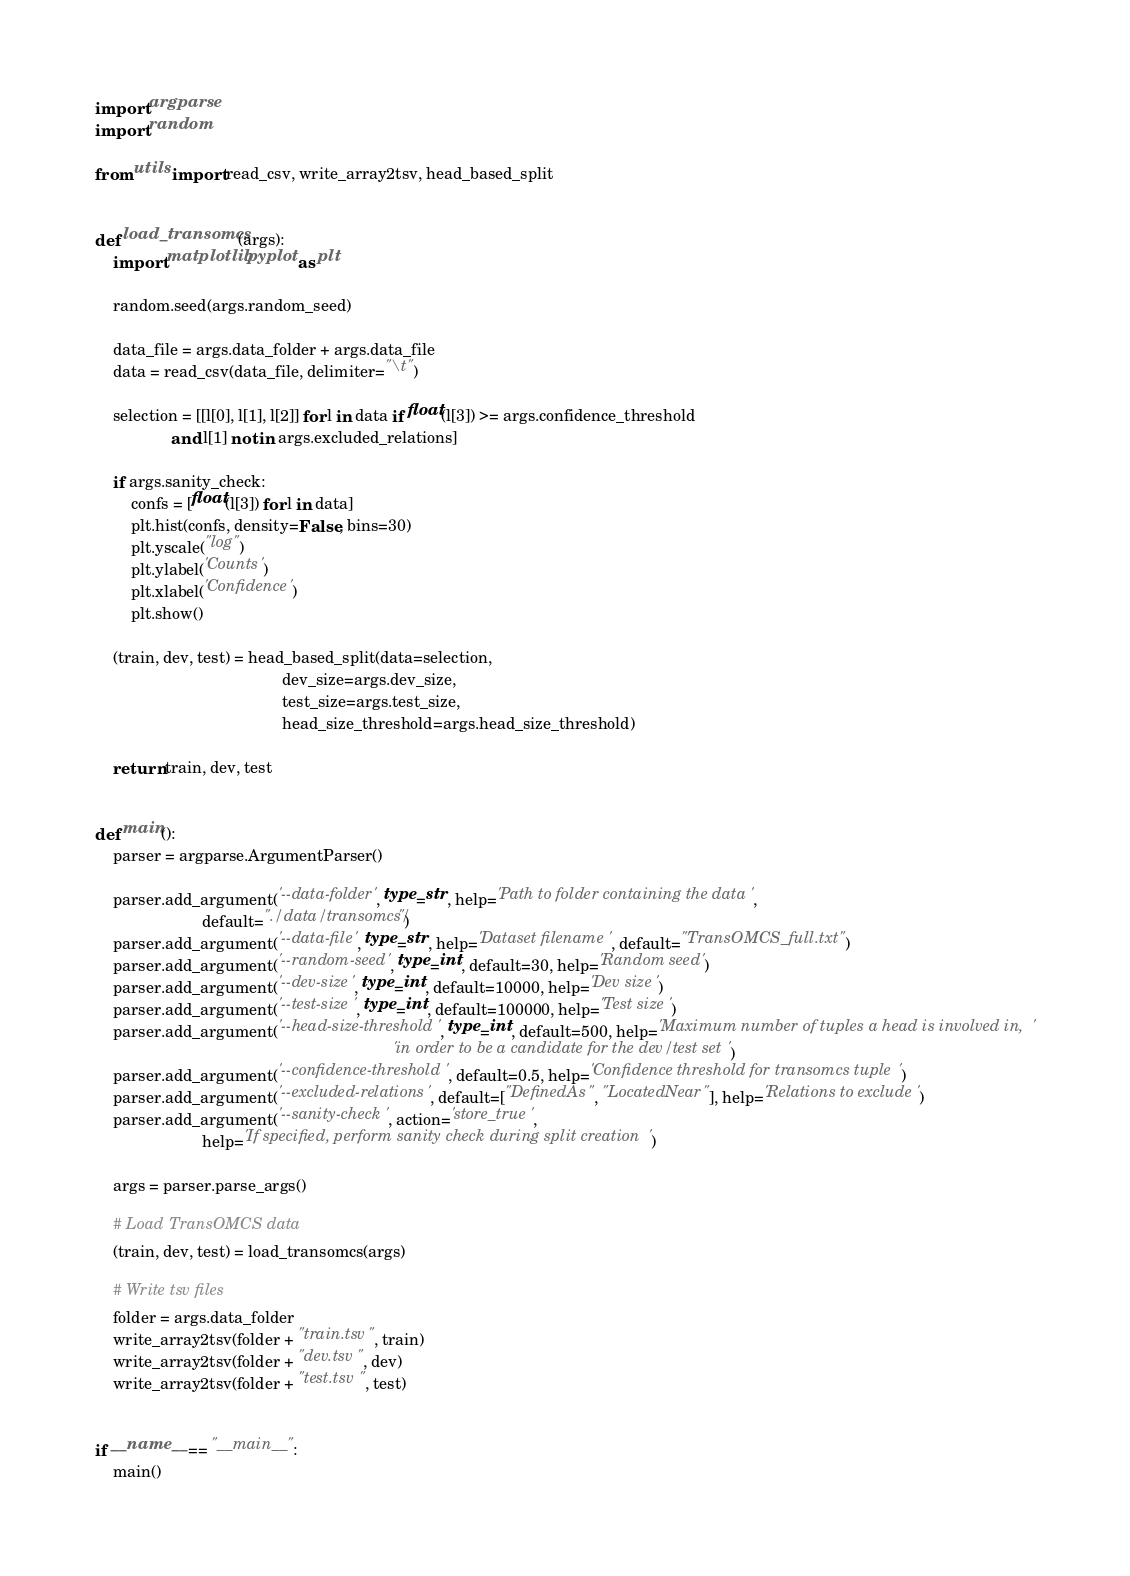Convert code to text. <code><loc_0><loc_0><loc_500><loc_500><_Python_>import argparse
import random

from utils import read_csv, write_array2tsv, head_based_split


def load_transomcs(args):
    import matplotlib.pyplot as plt

    random.seed(args.random_seed)

    data_file = args.data_folder + args.data_file
    data = read_csv(data_file, delimiter="\t")

    selection = [[l[0], l[1], l[2]] for l in data if float(l[3]) >= args.confidence_threshold
                 and l[1] not in args.excluded_relations]

    if args.sanity_check:
        confs = [float(l[3]) for l in data]
        plt.hist(confs, density=False, bins=30)
        plt.yscale("log")
        plt.ylabel('Counts')
        plt.xlabel('Confidence')
        plt.show()

    (train, dev, test) = head_based_split(data=selection,
                                          dev_size=args.dev_size,
                                          test_size=args.test_size,
                                          head_size_threshold=args.head_size_threshold)

    return train, dev, test


def main():
    parser = argparse.ArgumentParser()

    parser.add_argument('--data-folder', type=str, help='Path to folder containing the data',
                        default="./data/transomcs/")
    parser.add_argument('--data-file', type=str, help='Dataset filename', default="TransOMCS_full.txt")
    parser.add_argument('--random-seed', type=int, default=30, help='Random seed')
    parser.add_argument('--dev-size', type=int, default=10000, help='Dev size')
    parser.add_argument('--test-size', type=int, default=100000, help='Test size')
    parser.add_argument('--head-size-threshold', type=int, default=500, help='Maximum number of tuples a head is involved in, '
                                                                   'in order to be a candidate for the dev/test set')
    parser.add_argument('--confidence-threshold', default=0.5, help='Confidence threshold for transomcs tuple')
    parser.add_argument('--excluded-relations', default=["DefinedAs", "LocatedNear"], help='Relations to exclude')
    parser.add_argument('--sanity-check', action='store_true',
                        help='If specified, perform sanity check during split creation')

    args = parser.parse_args()

    # Load TransOMCS data
    (train, dev, test) = load_transomcs(args)

    # Write tsv files
    folder = args.data_folder
    write_array2tsv(folder + "train.tsv", train)
    write_array2tsv(folder + "dev.tsv", dev)
    write_array2tsv(folder + "test.tsv", test)


if __name__ == "__main__":
    main()
</code> 